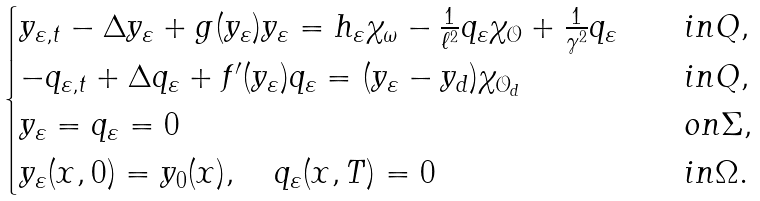Convert formula to latex. <formula><loc_0><loc_0><loc_500><loc_500>\begin{cases} y _ { \varepsilon , t } - \Delta y _ { \varepsilon } + g ( y _ { \varepsilon } ) y _ { \varepsilon } = h _ { \varepsilon } \chi _ { \omega } - \frac { 1 } { \ell ^ { 2 } } q _ { \varepsilon } \chi _ { \mathcal { O } } + \frac { 1 } { \gamma ^ { 2 } } q _ { \varepsilon } & \quad i n Q , \\ - q _ { \varepsilon , t } + \Delta q _ { \varepsilon } + f ^ { \prime } ( y _ { \varepsilon } ) q _ { \varepsilon } = ( y _ { \varepsilon } - y _ { d } ) \chi _ { \mathcal { O } _ { d } } & \quad i n Q , \\ y _ { \varepsilon } = q _ { \varepsilon } = 0 & \quad o n \Sigma , \\ y _ { \varepsilon } ( x , 0 ) = y _ { 0 } ( x ) , \quad q _ { \varepsilon } ( x , T ) = 0 & \quad i n \Omega . \end{cases}</formula> 